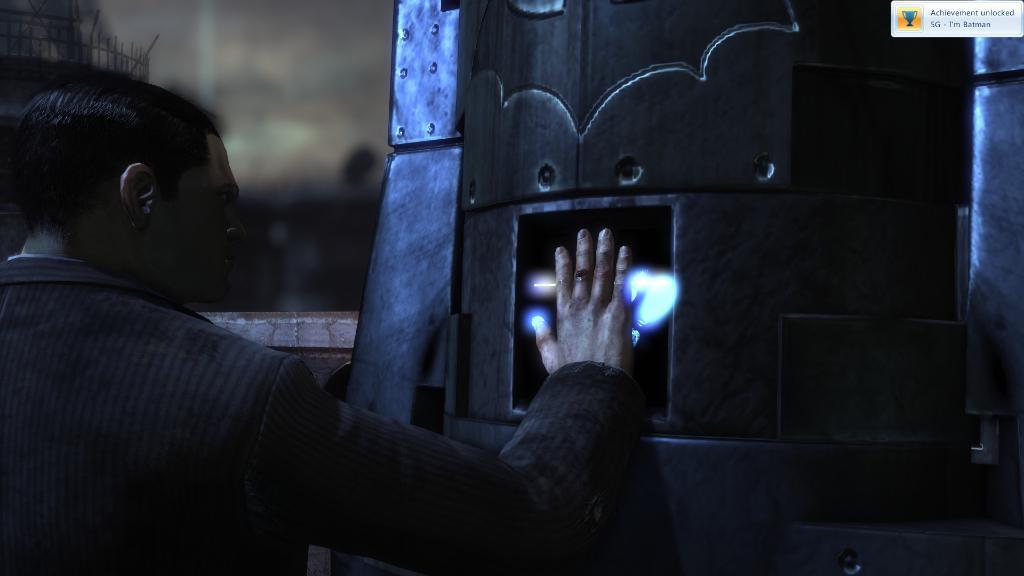Can you describe this image briefly? In the picture we can see a man standing and touching an object. 